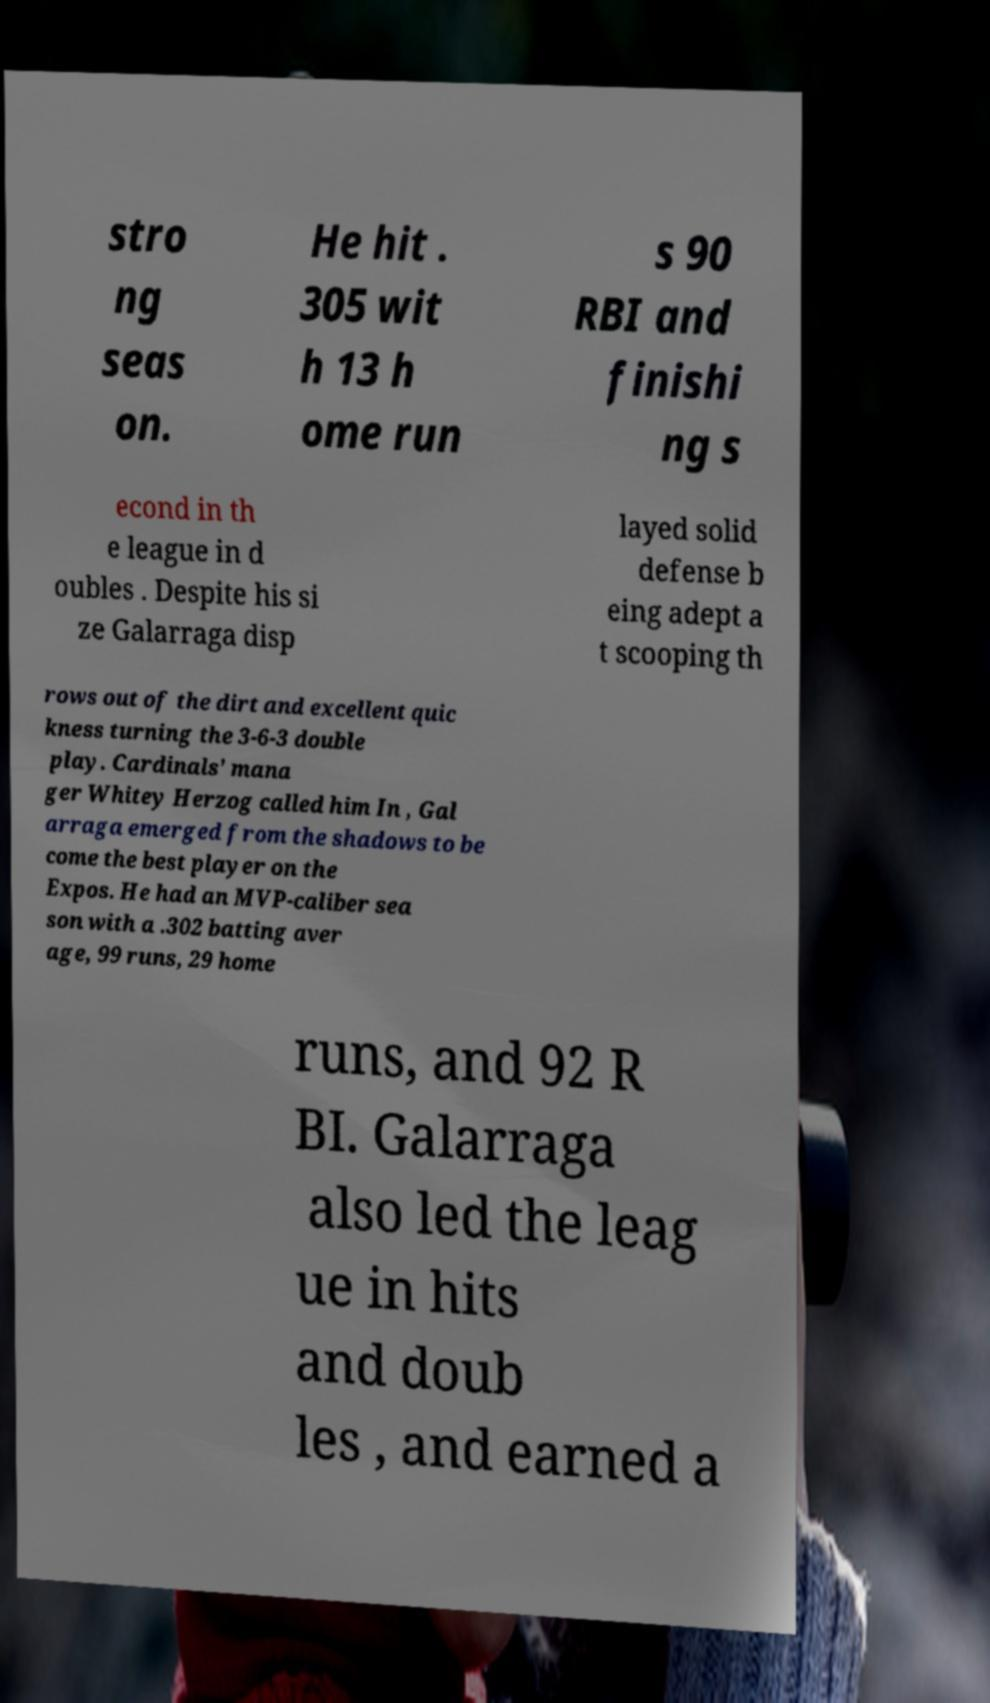What messages or text are displayed in this image? I need them in a readable, typed format. stro ng seas on. He hit . 305 wit h 13 h ome run s 90 RBI and finishi ng s econd in th e league in d oubles . Despite his si ze Galarraga disp layed solid defense b eing adept a t scooping th rows out of the dirt and excellent quic kness turning the 3-6-3 double play. Cardinals' mana ger Whitey Herzog called him In , Gal arraga emerged from the shadows to be come the best player on the Expos. He had an MVP-caliber sea son with a .302 batting aver age, 99 runs, 29 home runs, and 92 R BI. Galarraga also led the leag ue in hits and doub les , and earned a 